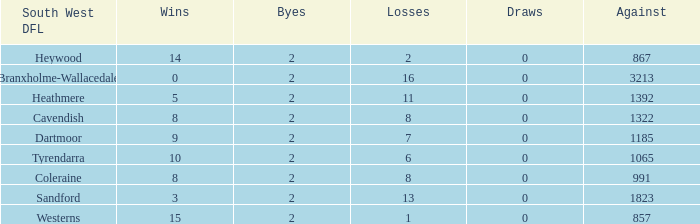How many wins have 16 losses and an Against smaller than 3213? None. 